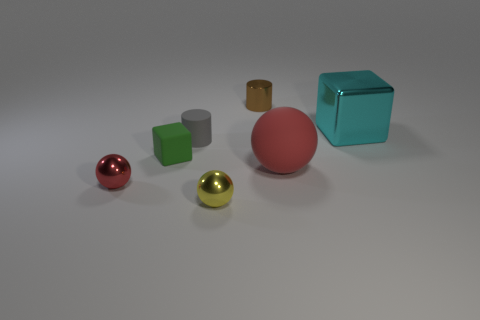What number of shiny objects are the same color as the big ball?
Ensure brevity in your answer.  1. What number of objects are either rubber objects that are in front of the rubber block or metal things that are on the right side of the green thing?
Your response must be concise. 4. There is a big shiny object that is the same shape as the tiny green rubber thing; what color is it?
Your answer should be compact. Cyan. Does the yellow metallic thing have the same shape as the red object that is behind the small red object?
Provide a short and direct response. Yes. What material is the large cyan thing?
Provide a short and direct response. Metal. There is a red matte object that is the same shape as the yellow shiny thing; what is its size?
Your answer should be very brief. Large. What number of other things are made of the same material as the small cube?
Make the answer very short. 2. Do the tiny gray object and the small object behind the large cyan metallic block have the same material?
Your response must be concise. No. Is the number of small metal spheres that are behind the tiny matte cube less than the number of small metallic objects that are behind the tiny red metallic object?
Provide a succinct answer. Yes. There is a large thing that is in front of the green matte cube; what color is it?
Offer a very short reply. Red. 